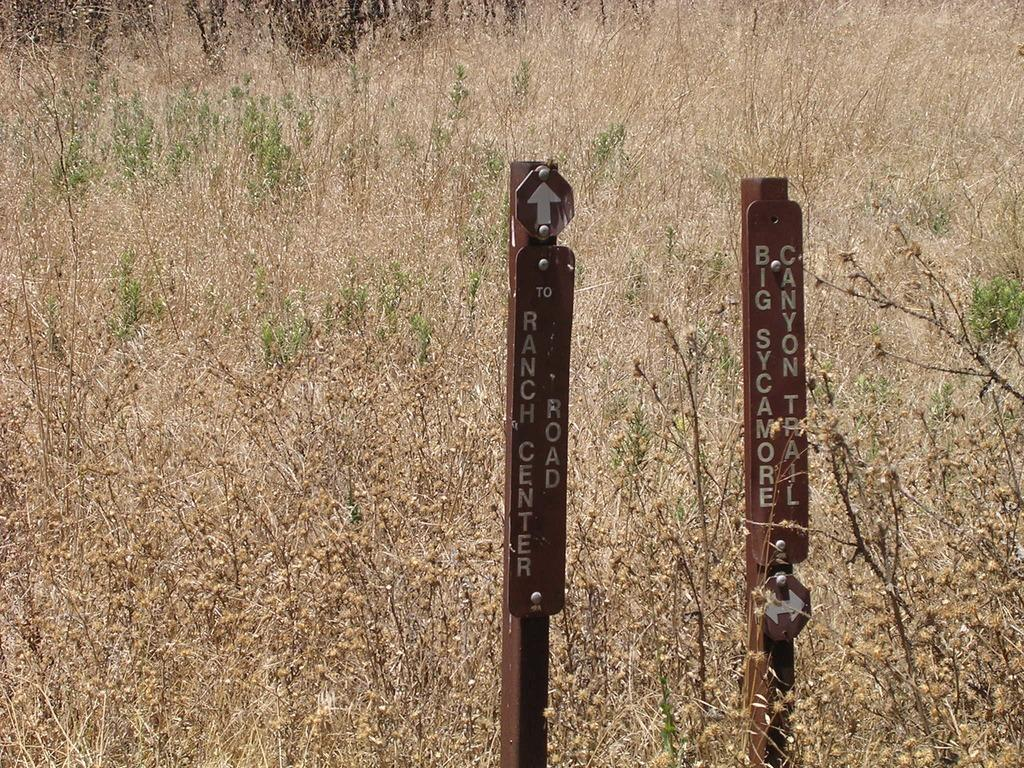What is the primary subject of the image? The primary subject of the image is the many plants. Are there any structures or objects visible in the image? Yes, there are two poles in the image. What type of lunch is being served to the children in the image? There are no children or lunch present in the image; it only features plants and poles. 